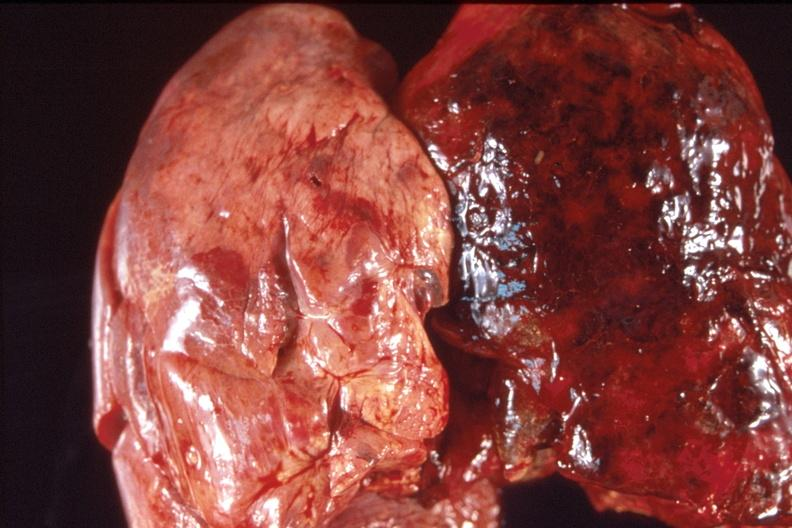s this close-up of cut surface infiltrates present?
Answer the question using a single word or phrase. No 